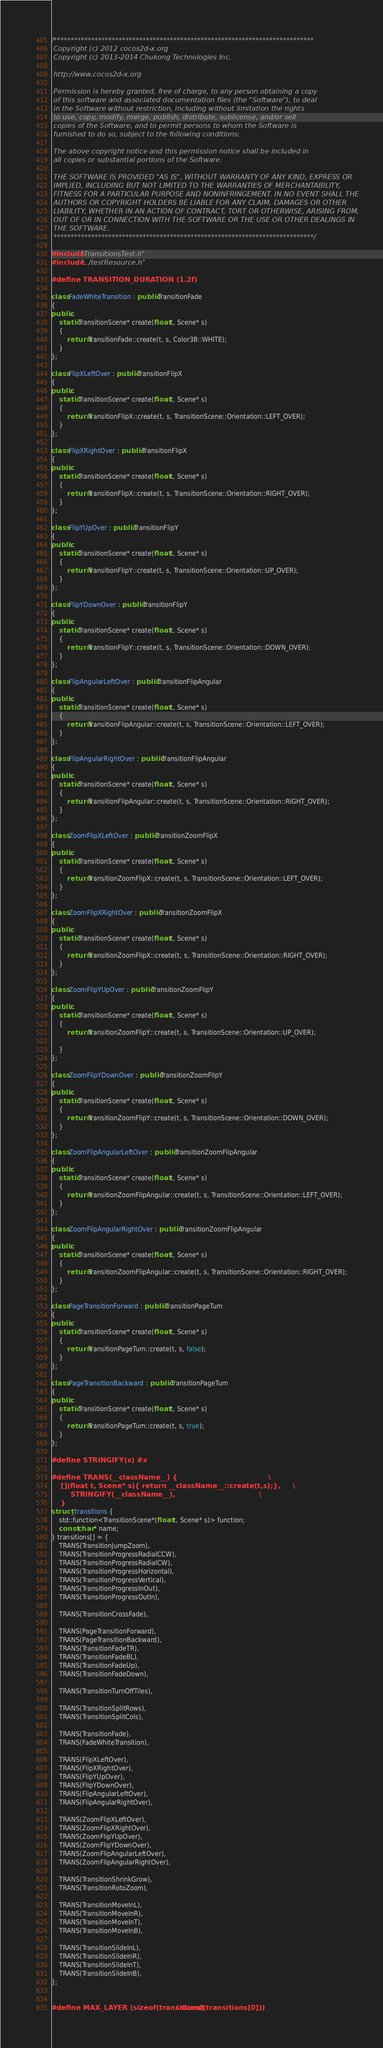<code> <loc_0><loc_0><loc_500><loc_500><_C++_>/****************************************************************************
 Copyright (c) 2012 cocos2d-x.org
 Copyright (c) 2013-2014 Chukong Technologies Inc.

 http://www.cocos2d-x.org

 Permission is hereby granted, free of charge, to any person obtaining a copy
 of this software and associated documentation files (the "Software"), to deal
 in the Software without restriction, including without limitation the rights
 to use, copy, modify, merge, publish, distribute, sublicense, and/or sell
 copies of the Software, and to permit persons to whom the Software is
 furnished to do so, subject to the following conditions:

 The above copyright notice and this permission notice shall be included in
 all copies or substantial portions of the Software.

 THE SOFTWARE IS PROVIDED "AS IS", WITHOUT WARRANTY OF ANY KIND, EXPRESS OR
 IMPLIED, INCLUDING BUT NOT LIMITED TO THE WARRANTIES OF MERCHANTABILITY,
 FITNESS FOR A PARTICULAR PURPOSE AND NONINFRINGEMENT. IN NO EVENT SHALL THE
 AUTHORS OR COPYRIGHT HOLDERS BE LIABLE FOR ANY CLAIM, DAMAGES OR OTHER
 LIABILITY, WHETHER IN AN ACTION OF CONTRACT, TORT OR OTHERWISE, ARISING FROM,
 OUT OF OR IN CONNECTION WITH THE SOFTWARE OR THE USE OR OTHER DEALINGS IN
 THE SOFTWARE.
 ****************************************************************************/

#include "TransitionsTest.h"
#include "../testResource.h"

#define TRANSITION_DURATION (1.2f)

class FadeWhiteTransition : public TransitionFade 
{
public:
    static TransitionScene* create(float t, Scene* s)
    {
        return TransitionFade::create(t, s, Color3B::WHITE); 
    }
};

class FlipXLeftOver : public TransitionFlipX 
{
public:
    static TransitionScene* create(float t, Scene* s)
    {
        return TransitionFlipX::create(t, s, TransitionScene::Orientation::LEFT_OVER);
    }
};

class FlipXRightOver : public TransitionFlipX 
{
public:
    static TransitionScene* create(float t, Scene* s)
    {
        return TransitionFlipX::create(t, s, TransitionScene::Orientation::RIGHT_OVER);
    }
};

class FlipYUpOver : public TransitionFlipY 
{
public:
    static TransitionScene* create(float t, Scene* s)
    {
        return TransitionFlipY::create(t, s, TransitionScene::Orientation::UP_OVER); 
    }
};

class FlipYDownOver : public TransitionFlipY 
{
public:
    static TransitionScene* create(float t, Scene* s)
    {
        return TransitionFlipY::create(t, s, TransitionScene::Orientation::DOWN_OVER); 
    }
};

class FlipAngularLeftOver : public TransitionFlipAngular 
{
public:
    static TransitionScene* create(float t, Scene* s)
    {
        return TransitionFlipAngular::create(t, s, TransitionScene::Orientation::LEFT_OVER); 
    }
};

class FlipAngularRightOver : public TransitionFlipAngular 
{
public:
    static TransitionScene* create(float t, Scene* s)
    {
        return TransitionFlipAngular::create(t, s, TransitionScene::Orientation::RIGHT_OVER);
    }
};

class ZoomFlipXLeftOver : public TransitionZoomFlipX 
{
public:
    static TransitionScene* create(float t, Scene* s)
    {
        return TransitionZoomFlipX::create(t, s, TransitionScene::Orientation::LEFT_OVER); 
    }
};

class ZoomFlipXRightOver : public TransitionZoomFlipX 
{
public:
    static TransitionScene* create(float t, Scene* s)
    {
        return TransitionZoomFlipX::create(t, s, TransitionScene::Orientation::RIGHT_OVER);
    }
};

class ZoomFlipYUpOver : public TransitionZoomFlipY 
{
public:
    static TransitionScene* create(float t, Scene* s)
    {
        return TransitionZoomFlipY::create(t, s, TransitionScene::Orientation::UP_OVER); 

    }
};

class ZoomFlipYDownOver : public TransitionZoomFlipY 
{
public:
    static TransitionScene* create(float t, Scene* s)
    {
        return TransitionZoomFlipY::create(t, s, TransitionScene::Orientation::DOWN_OVER); 
    }
};

class ZoomFlipAngularLeftOver : public TransitionZoomFlipAngular 
{
public:
    static TransitionScene* create(float t, Scene* s)
    {
        return TransitionZoomFlipAngular::create(t, s, TransitionScene::Orientation::LEFT_OVER); 
    }
};

class ZoomFlipAngularRightOver : public TransitionZoomFlipAngular 
{
public:
    static TransitionScene* create(float t, Scene* s)
    {
        return TransitionZoomFlipAngular::create(t, s, TransitionScene::Orientation::RIGHT_OVER);
    }
};

class PageTransitionForward : public TransitionPageTurn
{
public:
    static TransitionScene* create(float t, Scene* s)
    {
        return TransitionPageTurn::create(t, s, false);
    }
};

class PageTransitionBackward : public TransitionPageTurn
{
public:
    static TransitionScene* create(float t, Scene* s)
    {
        return TransitionPageTurn::create(t, s, true);
    }
};

#define STRINGIFY(x) #x

#define TRANS(__className__) {                                      \
    [](float t, Scene* s){ return __className__::create(t,s);},     \
        STRINGIFY(__className__),                                   \
    }
struct _transitions {
    std::function<TransitionScene*(float t, Scene* s)> function;
    const char * name;
} transitions[] = {
    TRANS(TransitionJumpZoom),
    TRANS(TransitionProgressRadialCCW),
    TRANS(TransitionProgressRadialCW),
    TRANS(TransitionProgressHorizontal),
    TRANS(TransitionProgressVertical),
    TRANS(TransitionProgressInOut),
    TRANS(TransitionProgressOutIn),

    TRANS(TransitionCrossFade),

    TRANS(PageTransitionForward),
    TRANS(PageTransitionBackward),
    TRANS(TransitionFadeTR),
    TRANS(TransitionFadeBL),
    TRANS(TransitionFadeUp),
    TRANS(TransitionFadeDown),

    TRANS(TransitionTurnOffTiles),

    TRANS(TransitionSplitRows),
    TRANS(TransitionSplitCols),

    TRANS(TransitionFade),
    TRANS(FadeWhiteTransition),

    TRANS(FlipXLeftOver),
    TRANS(FlipXRightOver),
    TRANS(FlipYUpOver),
    TRANS(FlipYDownOver),
    TRANS(FlipAngularLeftOver),
    TRANS(FlipAngularRightOver),

    TRANS(ZoomFlipXLeftOver),
    TRANS(ZoomFlipXRightOver),
    TRANS(ZoomFlipYUpOver),
    TRANS(ZoomFlipYDownOver),
    TRANS(ZoomFlipAngularLeftOver),
    TRANS(ZoomFlipAngularRightOver),

    TRANS(TransitionShrinkGrow),
    TRANS(TransitionRotoZoom),

    TRANS(TransitionMoveInL),
    TRANS(TransitionMoveInR),
    TRANS(TransitionMoveInT),
    TRANS(TransitionMoveInB),

    TRANS(TransitionSlideInL),
    TRANS(TransitionSlideInR),
    TRANS(TransitionSlideInT),
    TRANS(TransitionSlideInB),
};


#define MAX_LAYER (sizeof(transitions) / sizeof(transitions[0]))

</code> 